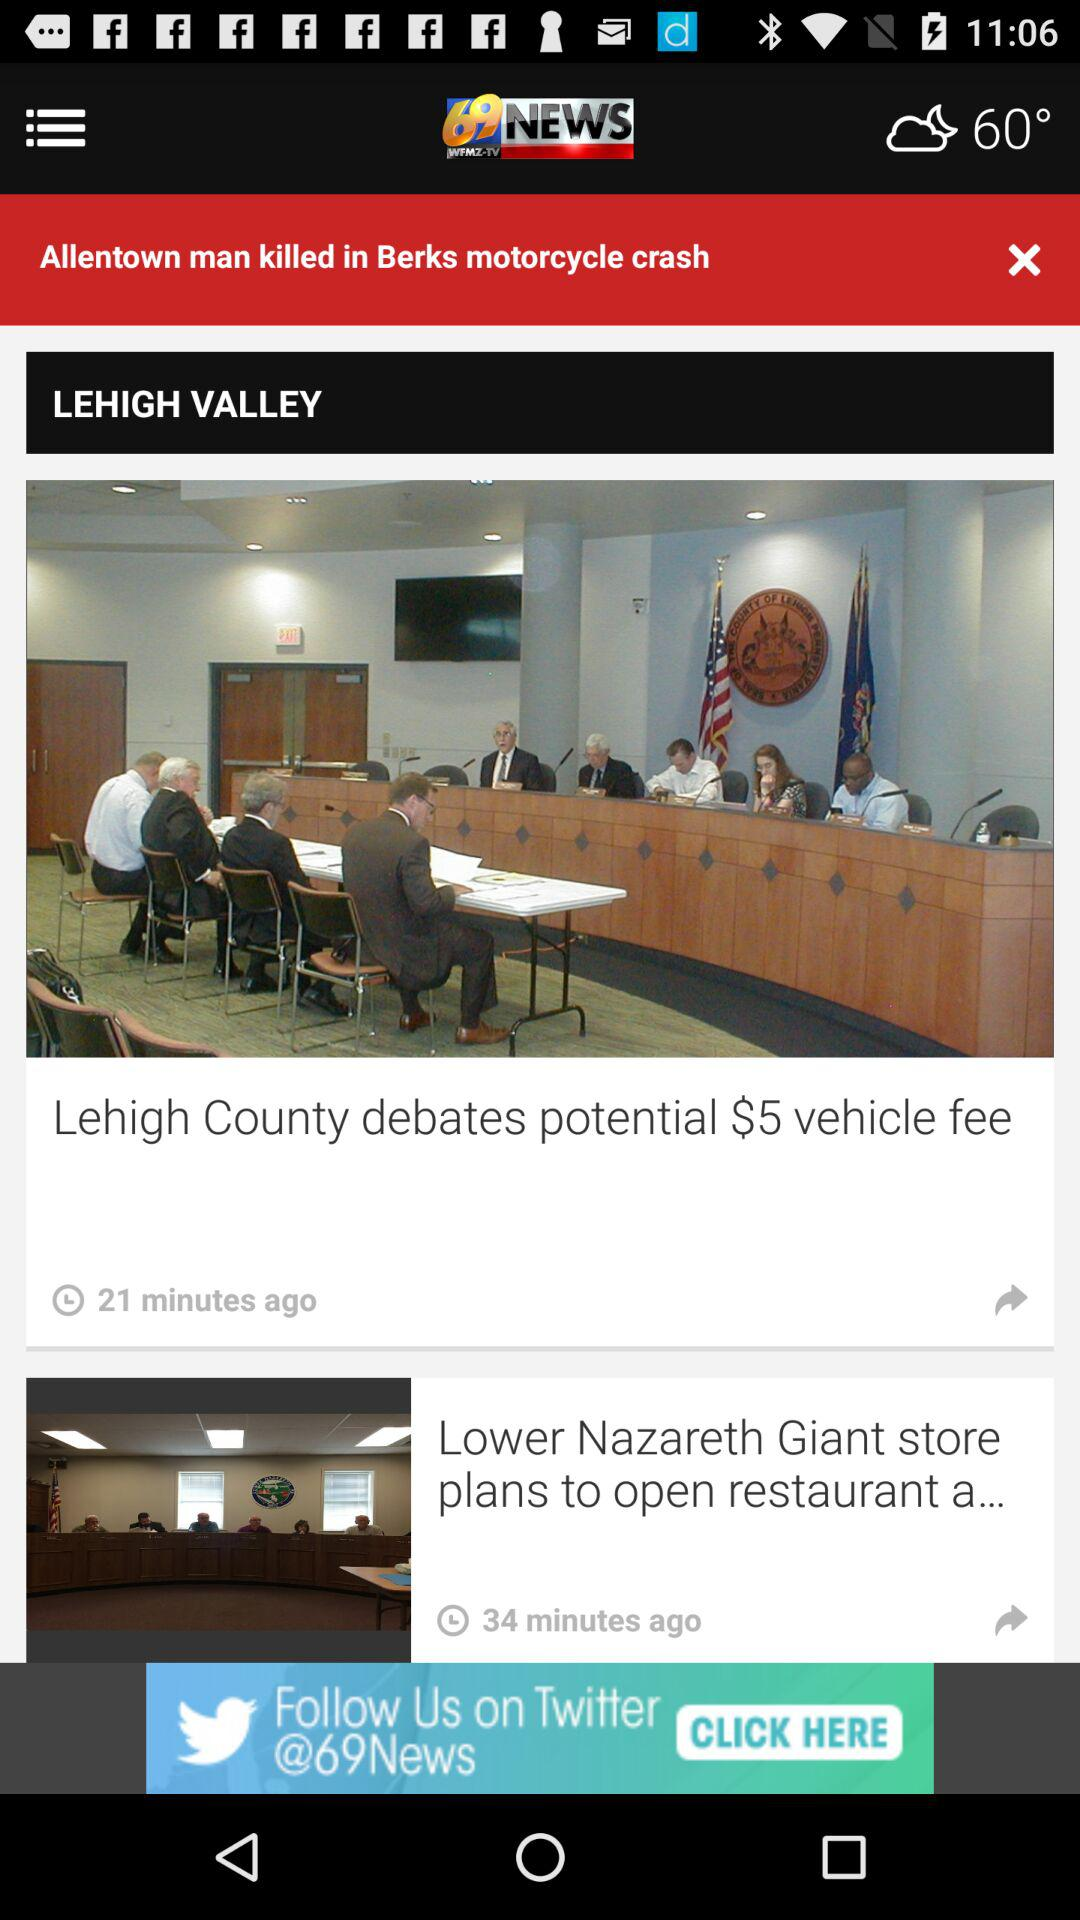What's the temperature? The temperature is 60°. 